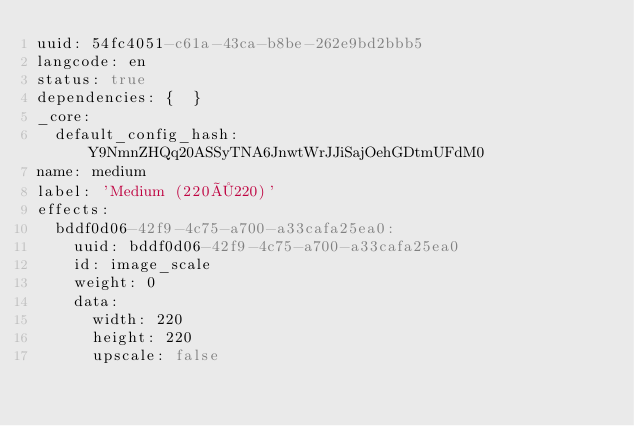Convert code to text. <code><loc_0><loc_0><loc_500><loc_500><_YAML_>uuid: 54fc4051-c61a-43ca-b8be-262e9bd2bbb5
langcode: en
status: true
dependencies: {  }
_core:
  default_config_hash: Y9NmnZHQq20ASSyTNA6JnwtWrJJiSajOehGDtmUFdM0
name: medium
label: 'Medium (220×220)'
effects:
  bddf0d06-42f9-4c75-a700-a33cafa25ea0:
    uuid: bddf0d06-42f9-4c75-a700-a33cafa25ea0
    id: image_scale
    weight: 0
    data:
      width: 220
      height: 220
      upscale: false
</code> 